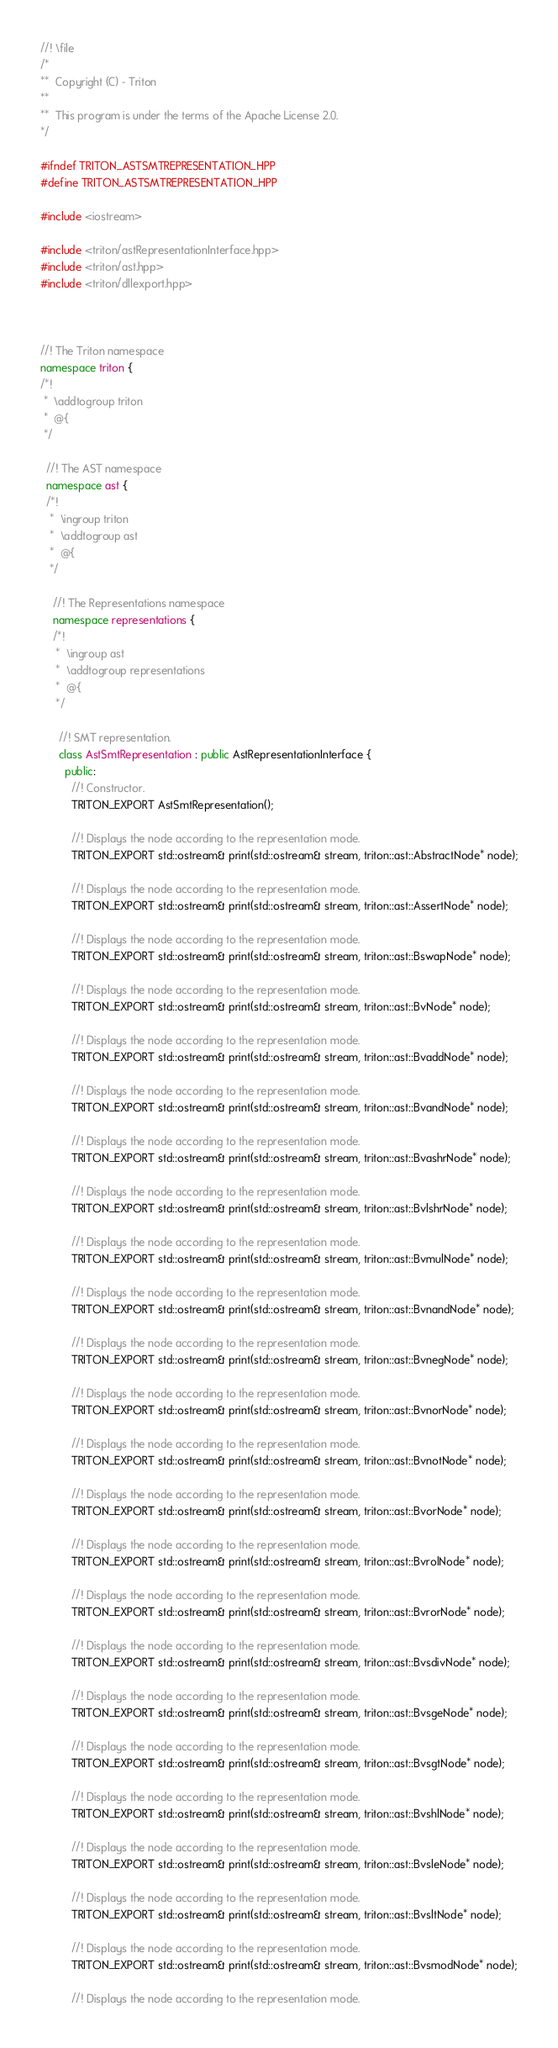<code> <loc_0><loc_0><loc_500><loc_500><_C++_>//! \file
/*
**  Copyright (C) - Triton
**
**  This program is under the terms of the Apache License 2.0.
*/

#ifndef TRITON_ASTSMTREPRESENTATION_HPP
#define TRITON_ASTSMTREPRESENTATION_HPP

#include <iostream>

#include <triton/astRepresentationInterface.hpp>
#include <triton/ast.hpp>
#include <triton/dllexport.hpp>



//! The Triton namespace
namespace triton {
/*!
 *  \addtogroup triton
 *  @{
 */

  //! The AST namespace
  namespace ast {
  /*!
   *  \ingroup triton
   *  \addtogroup ast
   *  @{
   */

    //! The Representations namespace
    namespace representations {
    /*!
     *  \ingroup ast
     *  \addtogroup representations
     *  @{
     */

      //! SMT representation.
      class AstSmtRepresentation : public AstRepresentationInterface {
        public:
          //! Constructor.
          TRITON_EXPORT AstSmtRepresentation();

          //! Displays the node according to the representation mode.
          TRITON_EXPORT std::ostream& print(std::ostream& stream, triton::ast::AbstractNode* node);

          //! Displays the node according to the representation mode.
          TRITON_EXPORT std::ostream& print(std::ostream& stream, triton::ast::AssertNode* node);

          //! Displays the node according to the representation mode.
          TRITON_EXPORT std::ostream& print(std::ostream& stream, triton::ast::BswapNode* node);

          //! Displays the node according to the representation mode.
          TRITON_EXPORT std::ostream& print(std::ostream& stream, triton::ast::BvNode* node);

          //! Displays the node according to the representation mode.
          TRITON_EXPORT std::ostream& print(std::ostream& stream, triton::ast::BvaddNode* node);

          //! Displays the node according to the representation mode.
          TRITON_EXPORT std::ostream& print(std::ostream& stream, triton::ast::BvandNode* node);

          //! Displays the node according to the representation mode.
          TRITON_EXPORT std::ostream& print(std::ostream& stream, triton::ast::BvashrNode* node);

          //! Displays the node according to the representation mode.
          TRITON_EXPORT std::ostream& print(std::ostream& stream, triton::ast::BvlshrNode* node);

          //! Displays the node according to the representation mode.
          TRITON_EXPORT std::ostream& print(std::ostream& stream, triton::ast::BvmulNode* node);

          //! Displays the node according to the representation mode.
          TRITON_EXPORT std::ostream& print(std::ostream& stream, triton::ast::BvnandNode* node);

          //! Displays the node according to the representation mode.
          TRITON_EXPORT std::ostream& print(std::ostream& stream, triton::ast::BvnegNode* node);

          //! Displays the node according to the representation mode.
          TRITON_EXPORT std::ostream& print(std::ostream& stream, triton::ast::BvnorNode* node);

          //! Displays the node according to the representation mode.
          TRITON_EXPORT std::ostream& print(std::ostream& stream, triton::ast::BvnotNode* node);

          //! Displays the node according to the representation mode.
          TRITON_EXPORT std::ostream& print(std::ostream& stream, triton::ast::BvorNode* node);

          //! Displays the node according to the representation mode.
          TRITON_EXPORT std::ostream& print(std::ostream& stream, triton::ast::BvrolNode* node);

          //! Displays the node according to the representation mode.
          TRITON_EXPORT std::ostream& print(std::ostream& stream, triton::ast::BvrorNode* node);

          //! Displays the node according to the representation mode.
          TRITON_EXPORT std::ostream& print(std::ostream& stream, triton::ast::BvsdivNode* node);

          //! Displays the node according to the representation mode.
          TRITON_EXPORT std::ostream& print(std::ostream& stream, triton::ast::BvsgeNode* node);

          //! Displays the node according to the representation mode.
          TRITON_EXPORT std::ostream& print(std::ostream& stream, triton::ast::BvsgtNode* node);

          //! Displays the node according to the representation mode.
          TRITON_EXPORT std::ostream& print(std::ostream& stream, triton::ast::BvshlNode* node);

          //! Displays the node according to the representation mode.
          TRITON_EXPORT std::ostream& print(std::ostream& stream, triton::ast::BvsleNode* node);

          //! Displays the node according to the representation mode.
          TRITON_EXPORT std::ostream& print(std::ostream& stream, triton::ast::BvsltNode* node);

          //! Displays the node according to the representation mode.
          TRITON_EXPORT std::ostream& print(std::ostream& stream, triton::ast::BvsmodNode* node);

          //! Displays the node according to the representation mode.</code> 